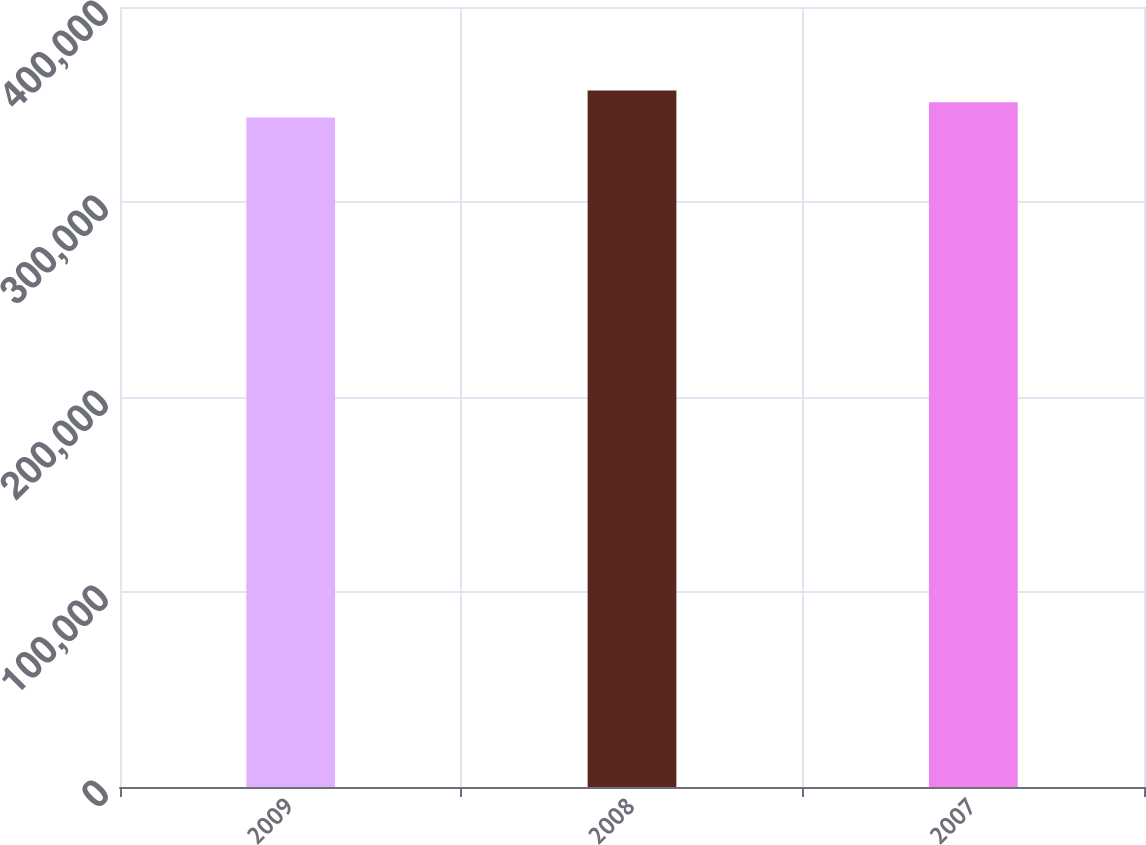Convert chart to OTSL. <chart><loc_0><loc_0><loc_500><loc_500><bar_chart><fcel>2009<fcel>2008<fcel>2007<nl><fcel>343370<fcel>357202<fcel>351209<nl></chart> 